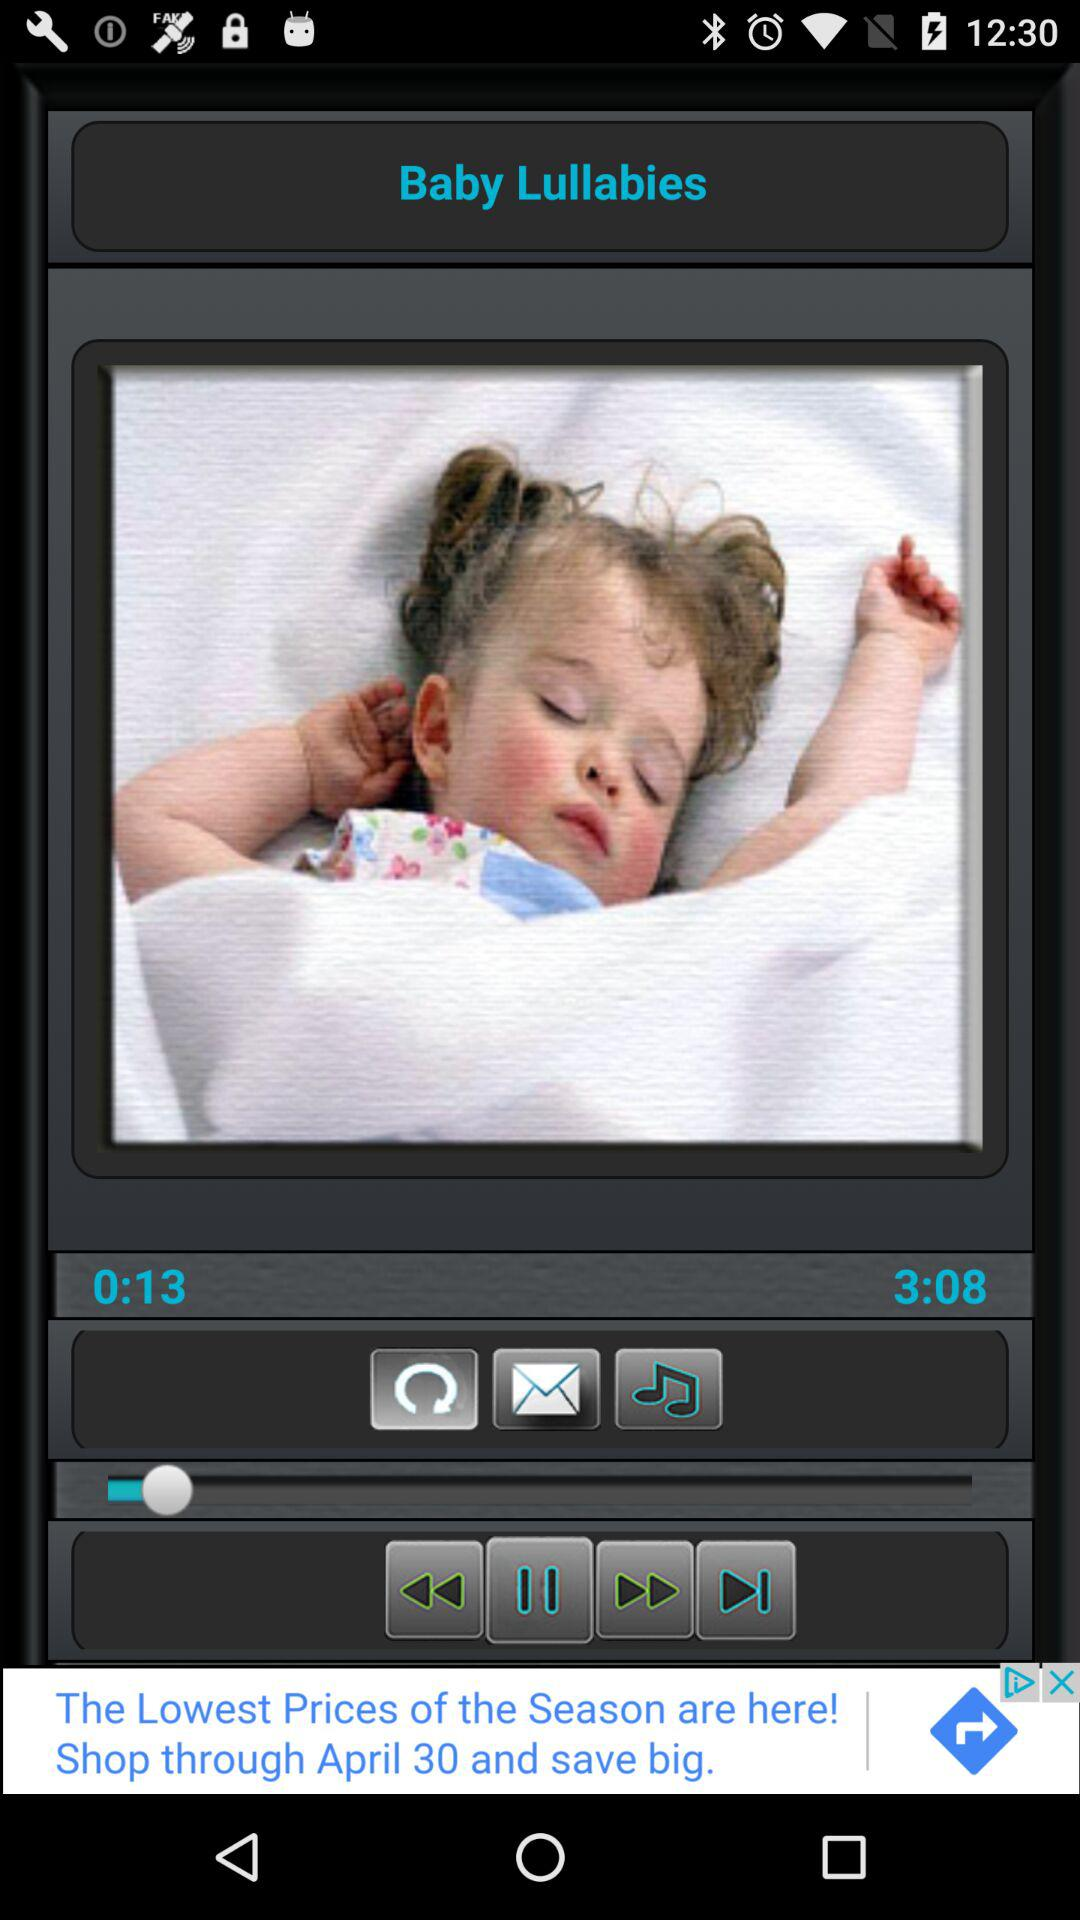What is the application name? The application name is "Baby Lullabies". 